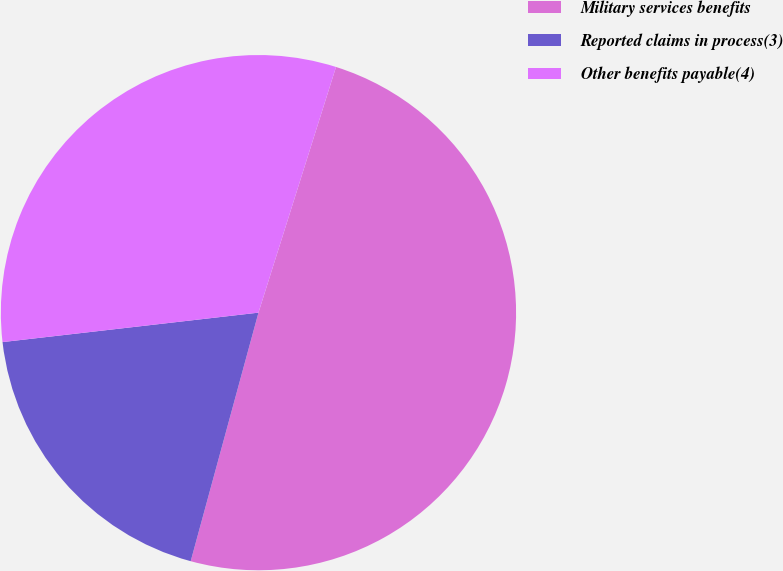Convert chart. <chart><loc_0><loc_0><loc_500><loc_500><pie_chart><fcel>Military services benefits<fcel>Reported claims in process(3)<fcel>Other benefits payable(4)<nl><fcel>49.37%<fcel>18.94%<fcel>31.69%<nl></chart> 